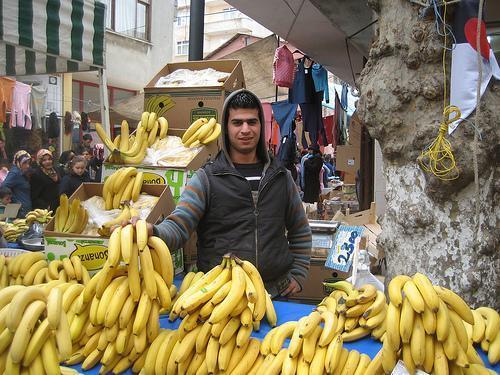How many numbers are on the sign?
Give a very brief answer. 4. 